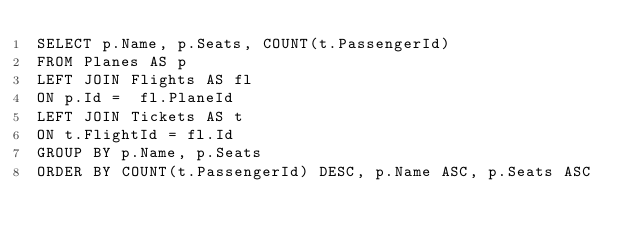Convert code to text. <code><loc_0><loc_0><loc_500><loc_500><_SQL_>SELECT p.Name, p.Seats, COUNT(t.PassengerId)
FROM Planes AS p
LEFT JOIN Flights AS fl
ON p.Id =  fl.PlaneId
LEFT JOIN Tickets AS t
ON t.FlightId = fl.Id
GROUP BY p.Name, p.Seats
ORDER BY COUNT(t.PassengerId) DESC, p.Name ASC, p.Seats ASC
</code> 